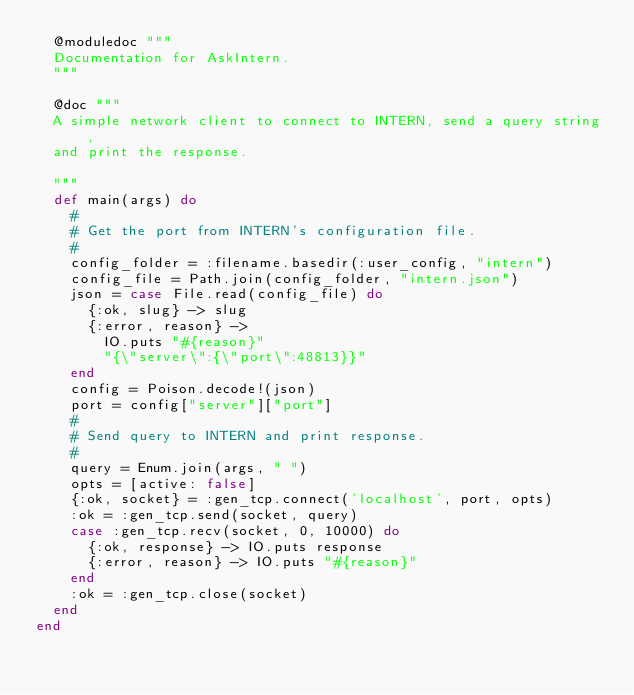<code> <loc_0><loc_0><loc_500><loc_500><_Elixir_>  @moduledoc """
  Documentation for AskIntern.
  """

  @doc """
  A simple network client to connect to INTERN, send a query string,
  and print the response.

  """
  def main(args) do
    #
    # Get the port from INTERN's configuration file.
    #
    config_folder = :filename.basedir(:user_config, "intern")
    config_file = Path.join(config_folder, "intern.json")
    json = case File.read(config_file) do
      {:ok, slug} -> slug
      {:error, reason} ->
        IO.puts "#{reason}"
        "{\"server\":{\"port\":48813}}"
    end
    config = Poison.decode!(json)
    port = config["server"]["port"]
    #
    # Send query to INTERN and print response.
    #
    query = Enum.join(args, " ")
    opts = [active: false]
    {:ok, socket} = :gen_tcp.connect('localhost', port, opts)
    :ok = :gen_tcp.send(socket, query)
    case :gen_tcp.recv(socket, 0, 10000) do
      {:ok, response} -> IO.puts response
      {:error, reason} -> IO.puts "#{reason}"
    end
    :ok = :gen_tcp.close(socket)
  end
end
</code> 